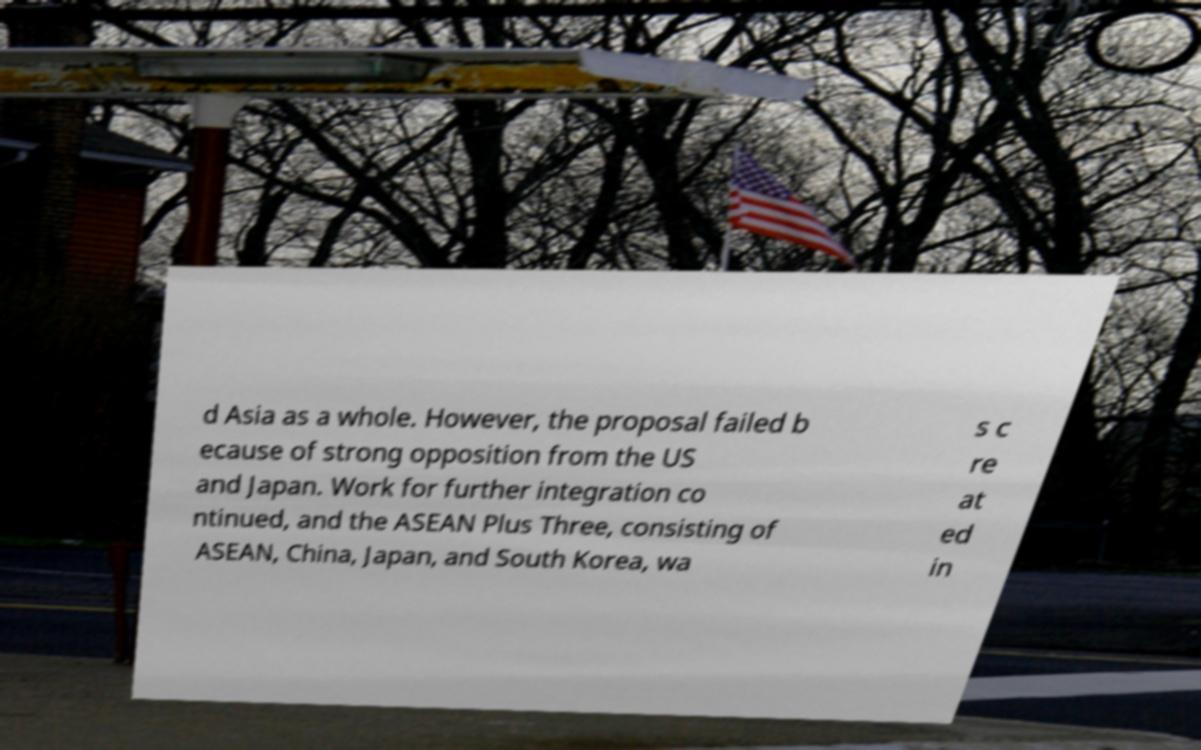Can you read and provide the text displayed in the image?This photo seems to have some interesting text. Can you extract and type it out for me? d Asia as a whole. However, the proposal failed b ecause of strong opposition from the US and Japan. Work for further integration co ntinued, and the ASEAN Plus Three, consisting of ASEAN, China, Japan, and South Korea, wa s c re at ed in 